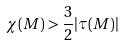Convert formula to latex. <formula><loc_0><loc_0><loc_500><loc_500>\chi ( M ) > \frac { 3 } { 2 } | \tau ( M ) |</formula> 